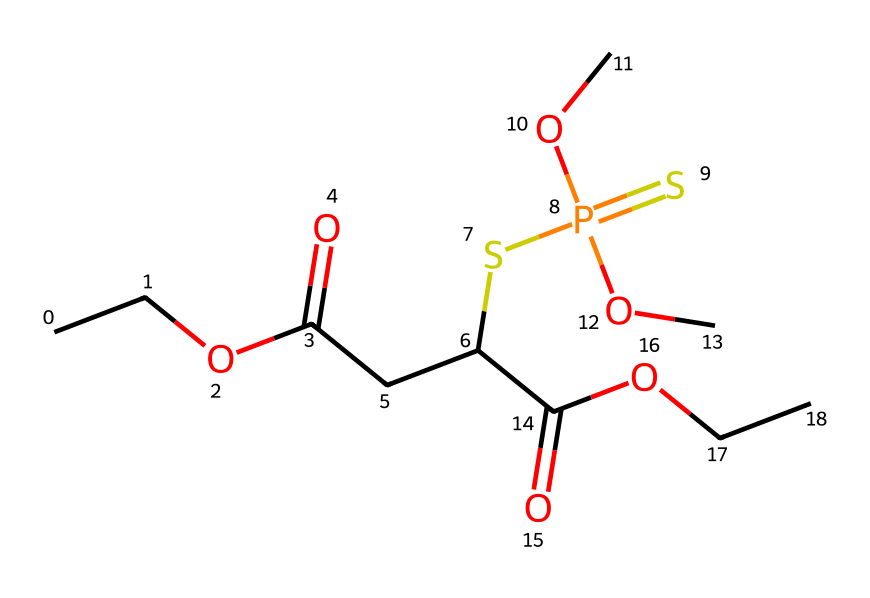What is the molecular weight of this chemical? To determine the molecular weight, we will calculate it based on the atomic weights of all the atoms in the structure, taking into account the number of each type of atom present. The chemical represents a compound with 12 carbons, 21 hydrogens, 6 oxygens, 1 sulfur, and 1 phosphorus. Adding their respective atomic weights (C: 12.01, H: 1.008, O: 16.00, S: 32.07, P: 30.97), we get the total molecular weight as 335.39 g/mol.
Answer: 335.39 g/mol How many oxygen atoms are present in the structure? By visually inspecting the chemical structure and counting the number of oxygen atoms indicated, we find there are a total of 6 oxygen atoms. Each oxygen atom is often represented by the letter "O" in the chemical structure.
Answer: 6 What functional groups are present in this molecule? Analyzing the structure, the functional groups include esters (indicated by the -COO- groups), sulfide (the -SP(=S) part), and carboxylic acids (indicated by -COOH). Both esters and carboxylic acids contain oxygen, while the sulfide group introduces sulfur.
Answer: esters, sulfide, carboxylic acids Is this chemical likely to be polar or nonpolar? The presence of polar functional groups such as carboxylic acids (-COOH) and oxygen-containing groups in the structure increases the molecule's polarity. Nonpolar molecules lack such groups, thus this complex structure suggests it is likely to be polar due to the strong electronegativity of oxygen and sulfur.
Answer: polar What type of bonding predominates in this chemical structure? The predominant type of bonding in this structure includes covalent bonds, as evidenced by the shared electron pairs primarily found between atoms such as carbon, hydrogen, oxygen, and sulfur. Covalent bonding is present in practically all organic compounds, which this is.
Answer: covalent bonds 